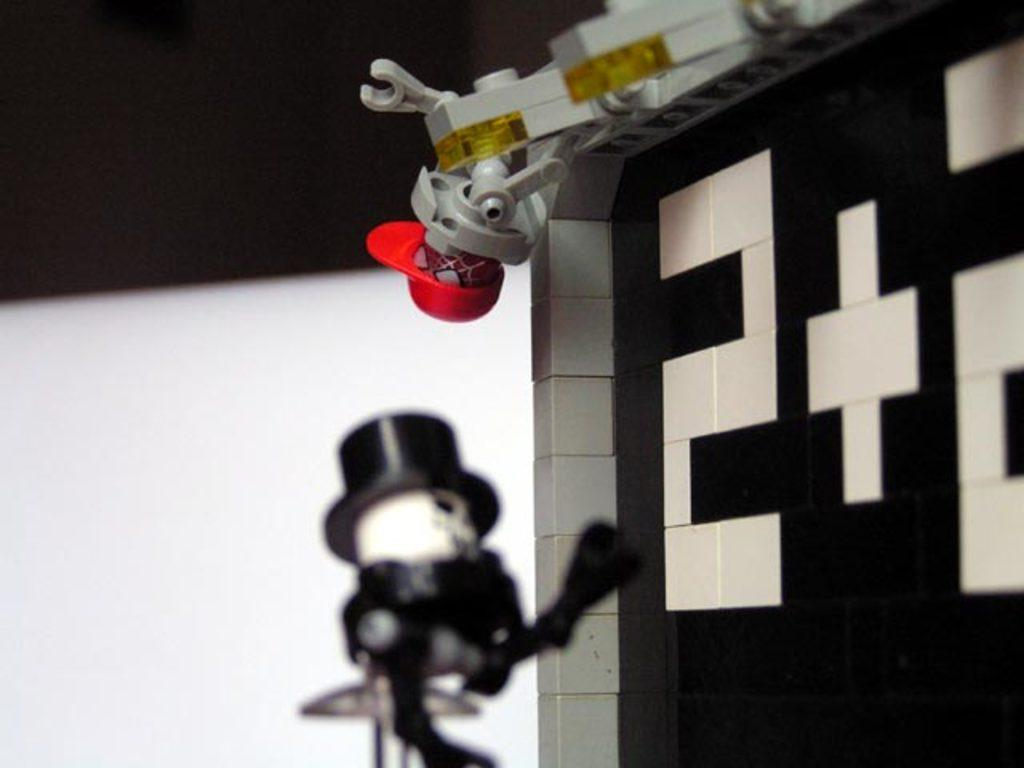What type of objects can be seen in the image? There are toys in the image. How are the toys constructed? The toys are built with blocks. Can you describe the arrangement of the toys in the image? The toys are distributed "here and there" in the image. What type of lettuce is being used to build the toys in the image? There is no lettuce present in the image; the toys are built with blocks. 